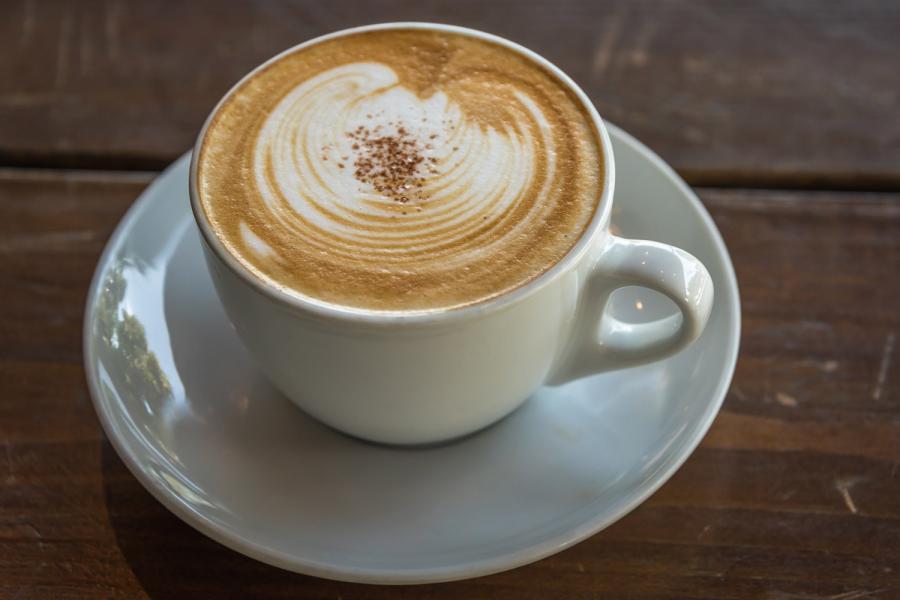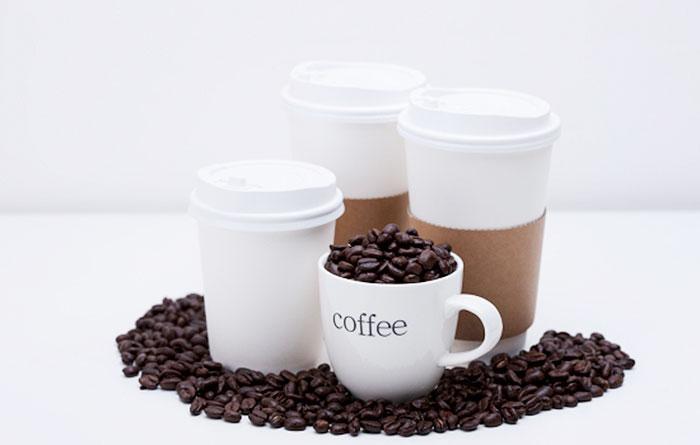The first image is the image on the left, the second image is the image on the right. Considering the images on both sides, is "There are at least three coffee cups in the left image." valid? Answer yes or no. No. The first image is the image on the left, the second image is the image on the right. Assess this claim about the two images: "There are three mugs filled with a cafe drink in the image on the left.". Correct or not? Answer yes or no. No. 